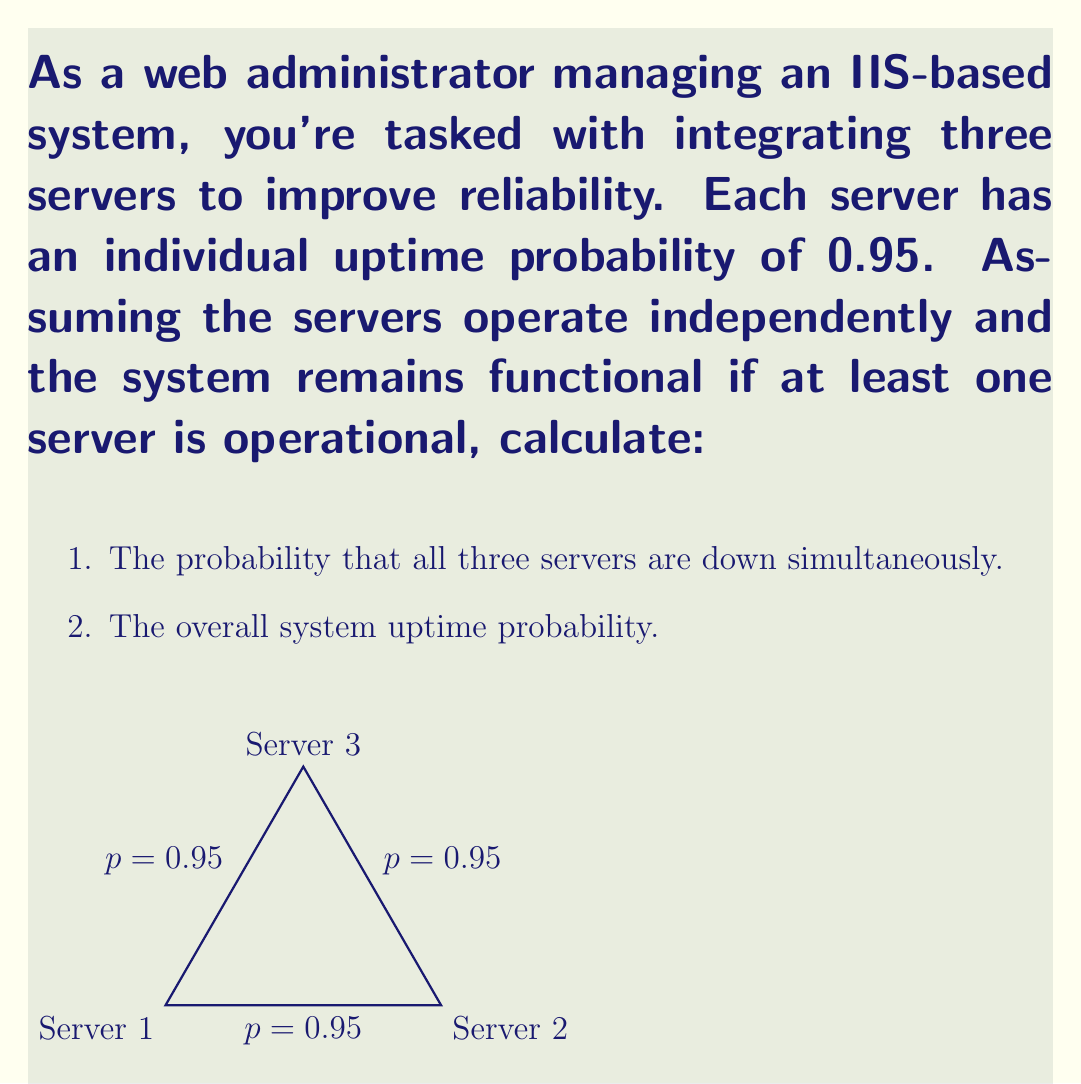Can you solve this math problem? Let's approach this step-by-step:

1. Probability that all three servers are down simultaneously:
   - Probability of one server being down = 1 - 0.95 = 0.05
   - For all three to be down: $P(\text{all down}) = 0.05 \times 0.05 \times 0.05$
   - $P(\text{all down}) = 0.05^3 = 0.000125$

2. Overall system uptime probability:
   - The system is up if at least one server is up
   - This is easier to calculate as 1 minus the probability that all servers are down
   - $P(\text{system up}) = 1 - P(\text{all down})$
   - $P(\text{system up}) = 1 - 0.000125 = 0.999875$

Alternatively, we can calculate this using the multiplication principle of probability:
   - $P(\text{system up}) = 1 - (1-0.95)^3 = 1 - 0.05^3 = 0.999875$

This result shows that integrating multiple servers significantly improves system reliability, which is crucial for maintaining high availability in web services.
Answer: 1. $0.000125$
2. $0.999875$ 